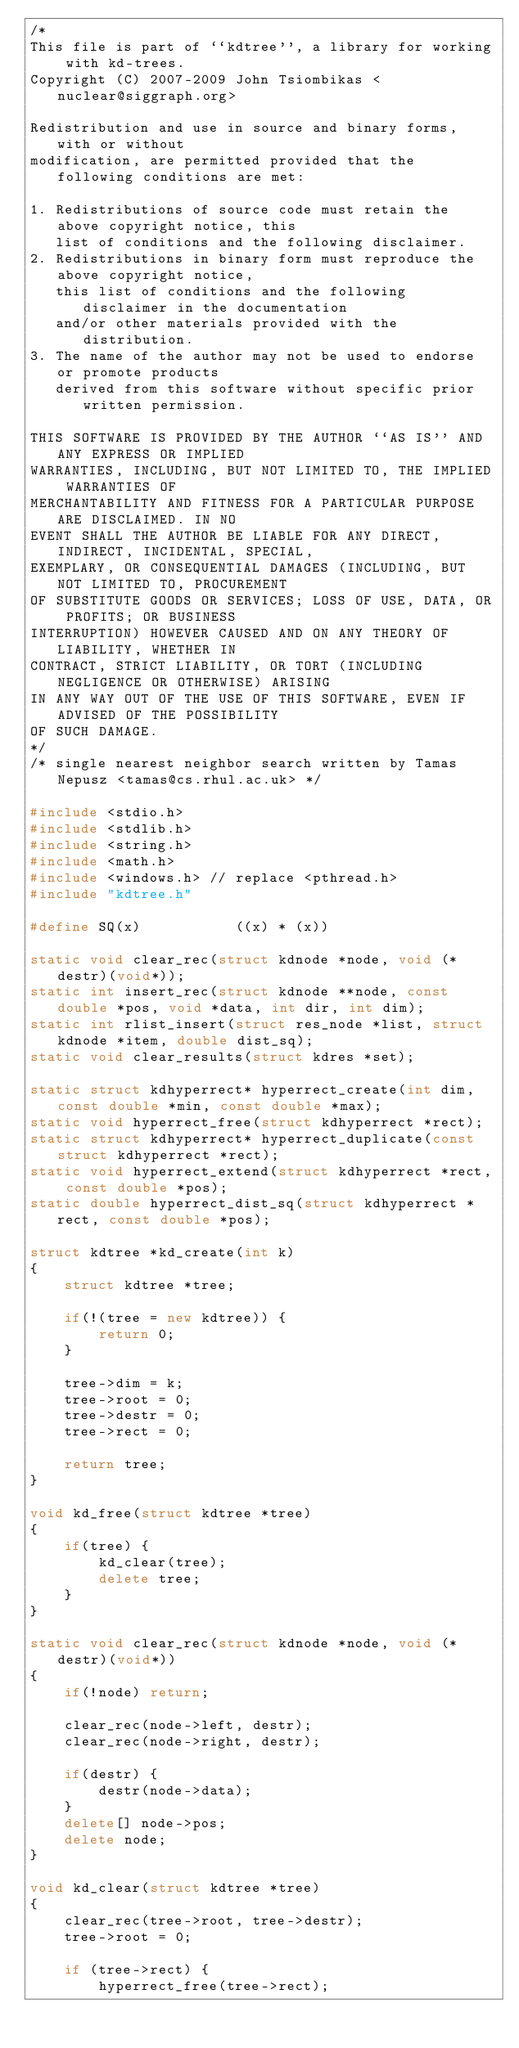Convert code to text. <code><loc_0><loc_0><loc_500><loc_500><_C++_>/*
This file is part of ``kdtree'', a library for working with kd-trees.
Copyright (C) 2007-2009 John Tsiombikas <nuclear@siggraph.org>

Redistribution and use in source and binary forms, with or without
modification, are permitted provided that the following conditions are met:

1. Redistributions of source code must retain the above copyright notice, this
   list of conditions and the following disclaimer.
2. Redistributions in binary form must reproduce the above copyright notice,
   this list of conditions and the following disclaimer in the documentation
   and/or other materials provided with the distribution.
3. The name of the author may not be used to endorse or promote products
   derived from this software without specific prior written permission.

THIS SOFTWARE IS PROVIDED BY THE AUTHOR ``AS IS'' AND ANY EXPRESS OR IMPLIED
WARRANTIES, INCLUDING, BUT NOT LIMITED TO, THE IMPLIED WARRANTIES OF
MERCHANTABILITY AND FITNESS FOR A PARTICULAR PURPOSE ARE DISCLAIMED. IN NO
EVENT SHALL THE AUTHOR BE LIABLE FOR ANY DIRECT, INDIRECT, INCIDENTAL, SPECIAL,
EXEMPLARY, OR CONSEQUENTIAL DAMAGES (INCLUDING, BUT NOT LIMITED TO, PROCUREMENT
OF SUBSTITUTE GOODS OR SERVICES; LOSS OF USE, DATA, OR PROFITS; OR BUSINESS
INTERRUPTION) HOWEVER CAUSED AND ON ANY THEORY OF LIABILITY, WHETHER IN
CONTRACT, STRICT LIABILITY, OR TORT (INCLUDING NEGLIGENCE OR OTHERWISE) ARISING
IN ANY WAY OUT OF THE USE OF THIS SOFTWARE, EVEN IF ADVISED OF THE POSSIBILITY
OF SUCH DAMAGE.
*/
/* single nearest neighbor search written by Tamas Nepusz <tamas@cs.rhul.ac.uk> */

#include <stdio.h>
#include <stdlib.h>
#include <string.h>
#include <math.h>
#include <windows.h> // replace <pthread.h>
#include "kdtree.h"

#define SQ(x)           ((x) * (x))

static void clear_rec(struct kdnode *node, void (*destr)(void*));
static int insert_rec(struct kdnode **node, const double *pos, void *data, int dir, int dim);
static int rlist_insert(struct res_node *list, struct kdnode *item, double dist_sq);
static void clear_results(struct kdres *set);

static struct kdhyperrect* hyperrect_create(int dim, const double *min, const double *max);
static void hyperrect_free(struct kdhyperrect *rect);
static struct kdhyperrect* hyperrect_duplicate(const struct kdhyperrect *rect);
static void hyperrect_extend(struct kdhyperrect *rect, const double *pos);
static double hyperrect_dist_sq(struct kdhyperrect *rect, const double *pos);

struct kdtree *kd_create(int k)
{
    struct kdtree *tree;

    if(!(tree = new kdtree)) {
        return 0;
    }

    tree->dim = k;
    tree->root = 0;
    tree->destr = 0;
    tree->rect = 0;

    return tree;
}

void kd_free(struct kdtree *tree)
{
    if(tree) {
        kd_clear(tree);
        delete tree;
    }
}

static void clear_rec(struct kdnode *node, void (*destr)(void*))
{
    if(!node) return;

    clear_rec(node->left, destr);
    clear_rec(node->right, destr);
    
    if(destr) {
        destr(node->data);
    }
    delete[] node->pos;
    delete node;
}

void kd_clear(struct kdtree *tree)
{
    clear_rec(tree->root, tree->destr);
    tree->root = 0;

    if (tree->rect) {
        hyperrect_free(tree->rect);</code> 